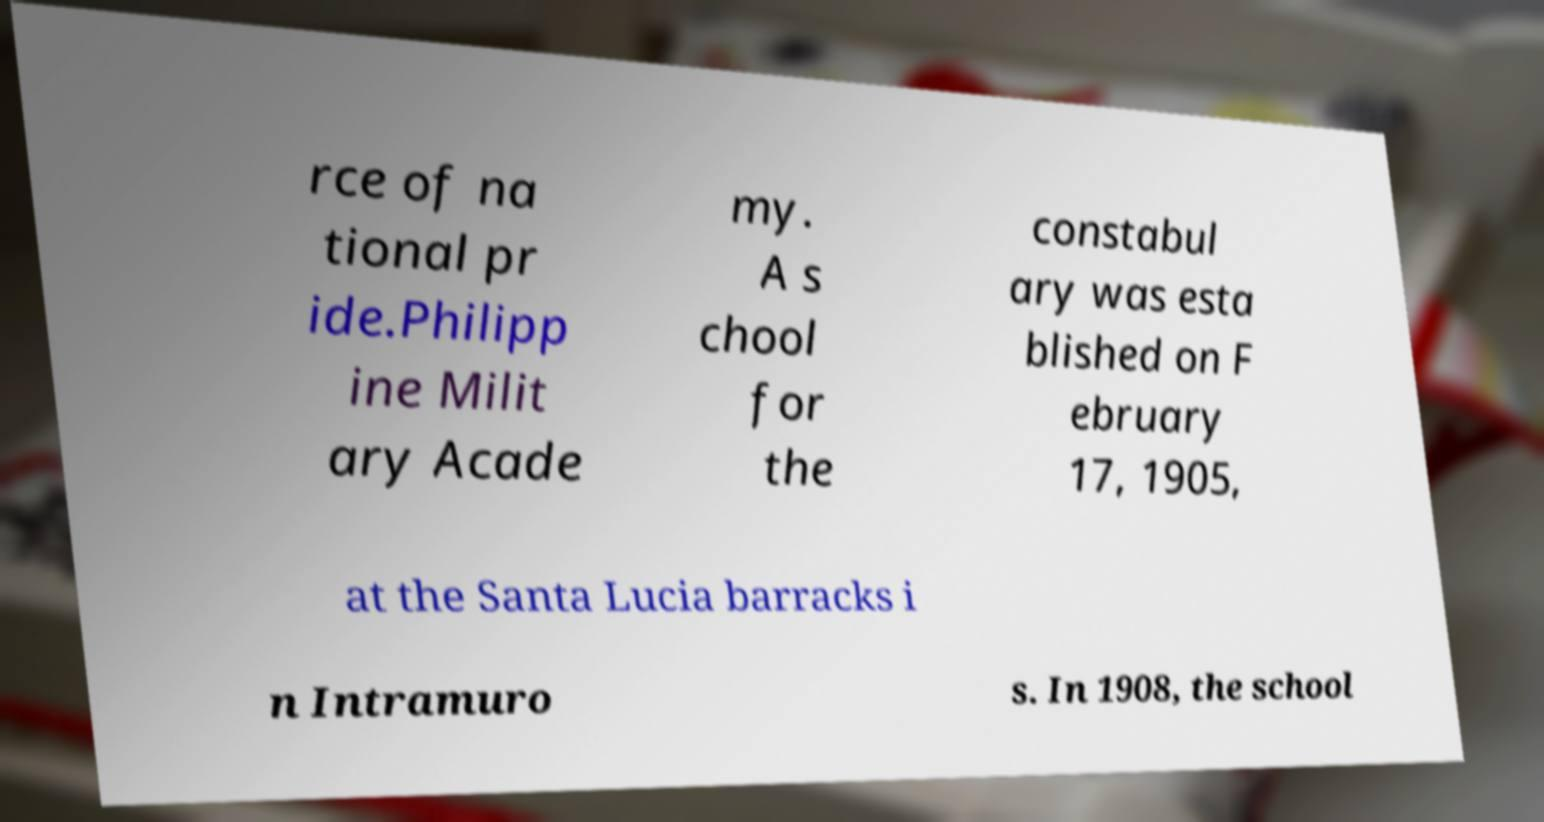What messages or text are displayed in this image? I need them in a readable, typed format. rce of na tional pr ide.Philipp ine Milit ary Acade my. A s chool for the constabul ary was esta blished on F ebruary 17, 1905, at the Santa Lucia barracks i n Intramuro s. In 1908, the school 